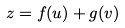<formula> <loc_0><loc_0><loc_500><loc_500>z = f ( u ) + g ( v )</formula> 